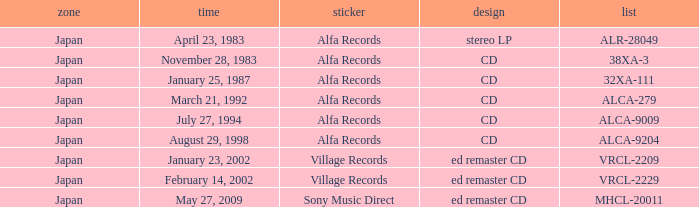Which region is identified as 38xa-3 in the catalog? Japan. 